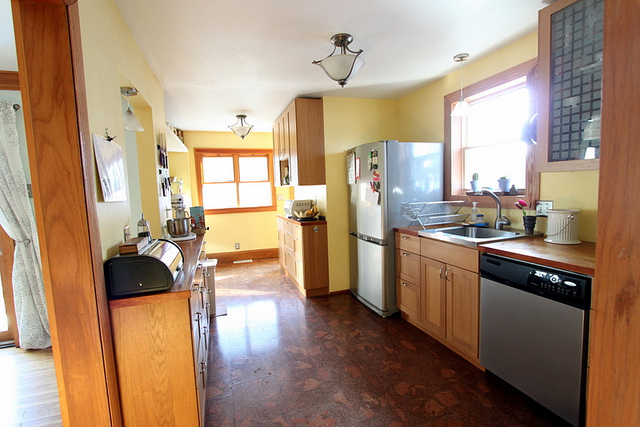Which room is this? This is a kitchen, as indicated by the presence of appliances such as a refrigerator and a dishwasher, along with a sink and cabinets typically found in kitchens. 